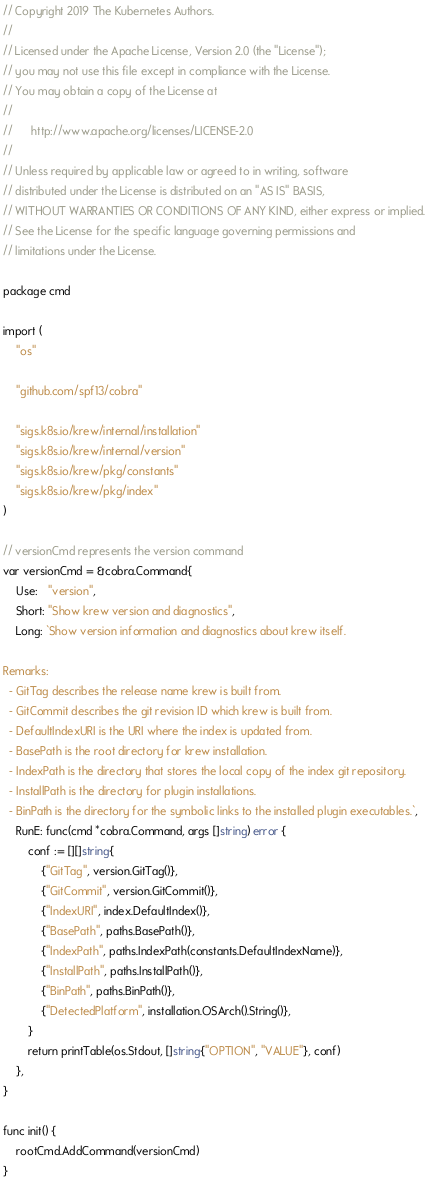<code> <loc_0><loc_0><loc_500><loc_500><_Go_>// Copyright 2019 The Kubernetes Authors.
//
// Licensed under the Apache License, Version 2.0 (the "License");
// you may not use this file except in compliance with the License.
// You may obtain a copy of the License at
//
//      http://www.apache.org/licenses/LICENSE-2.0
//
// Unless required by applicable law or agreed to in writing, software
// distributed under the License is distributed on an "AS IS" BASIS,
// WITHOUT WARRANTIES OR CONDITIONS OF ANY KIND, either express or implied.
// See the License for the specific language governing permissions and
// limitations under the License.

package cmd

import (
	"os"

	"github.com/spf13/cobra"

	"sigs.k8s.io/krew/internal/installation"
	"sigs.k8s.io/krew/internal/version"
	"sigs.k8s.io/krew/pkg/constants"
	"sigs.k8s.io/krew/pkg/index"
)

// versionCmd represents the version command
var versionCmd = &cobra.Command{
	Use:   "version",
	Short: "Show krew version and diagnostics",
	Long: `Show version information and diagnostics about krew itself.

Remarks:
  - GitTag describes the release name krew is built from.
  - GitCommit describes the git revision ID which krew is built from.
  - DefaultIndexURI is the URI where the index is updated from.
  - BasePath is the root directory for krew installation.
  - IndexPath is the directory that stores the local copy of the index git repository.
  - InstallPath is the directory for plugin installations.
  - BinPath is the directory for the symbolic links to the installed plugin executables.`,
	RunE: func(cmd *cobra.Command, args []string) error {
		conf := [][]string{
			{"GitTag", version.GitTag()},
			{"GitCommit", version.GitCommit()},
			{"IndexURI", index.DefaultIndex()},
			{"BasePath", paths.BasePath()},
			{"IndexPath", paths.IndexPath(constants.DefaultIndexName)},
			{"InstallPath", paths.InstallPath()},
			{"BinPath", paths.BinPath()},
			{"DetectedPlatform", installation.OSArch().String()},
		}
		return printTable(os.Stdout, []string{"OPTION", "VALUE"}, conf)
	},
}

func init() {
	rootCmd.AddCommand(versionCmd)
}
</code> 